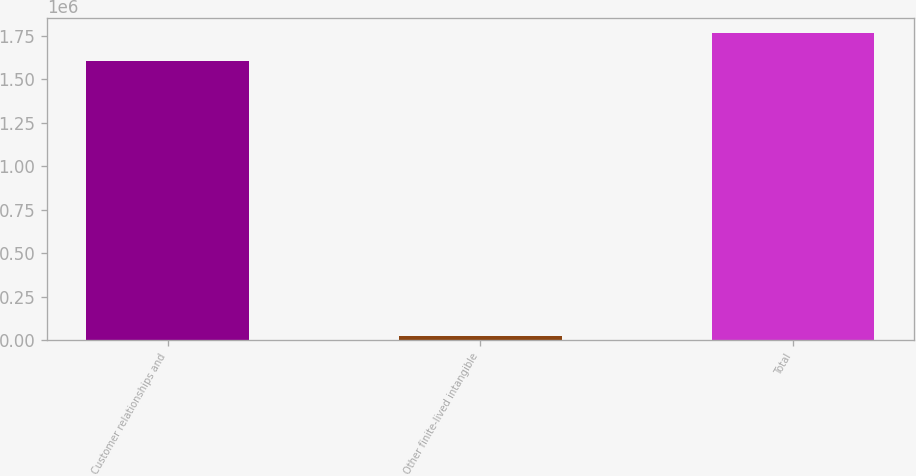Convert chart to OTSL. <chart><loc_0><loc_0><loc_500><loc_500><bar_chart><fcel>Customer relationships and<fcel>Other finite-lived intangible<fcel>Total<nl><fcel>1.60402e+06<fcel>24788<fcel>1.76442e+06<nl></chart> 